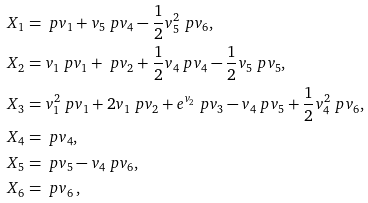<formula> <loc_0><loc_0><loc_500><loc_500>X _ { 1 } & = \ p { v _ { 1 } } + v _ { 5 } \ p { v _ { 4 } } - \frac { 1 } { 2 } v _ { 5 } ^ { 2 } \ p { v _ { 6 } } , \\ X _ { 2 } & = v _ { 1 } \ p { v _ { 1 } } + \ p { v _ { 2 } } + \frac { 1 } { 2 } v _ { 4 } \ p { v _ { 4 } } - \frac { 1 } { 2 } v _ { 5 } \ p { v _ { 5 } } , \\ X _ { 3 } & = v _ { 1 } ^ { 2 } \ p { v _ { 1 } } + 2 v _ { 1 } \ p { v _ { 2 } } + e ^ { v _ { 2 } } \ p { v _ { 3 } } - v _ { 4 } \ p { v _ { 5 } } + \frac { 1 } { 2 } v _ { 4 } ^ { 2 } \ p { v _ { 6 } } , \\ X _ { 4 } & = \ p { v _ { 4 } } , \\ X _ { 5 } & = \ p { v _ { 5 } } - v _ { 4 } \ p { v _ { 6 } } , \\ X _ { 6 } & = \ p { v _ { 6 } } \, , \\</formula> 